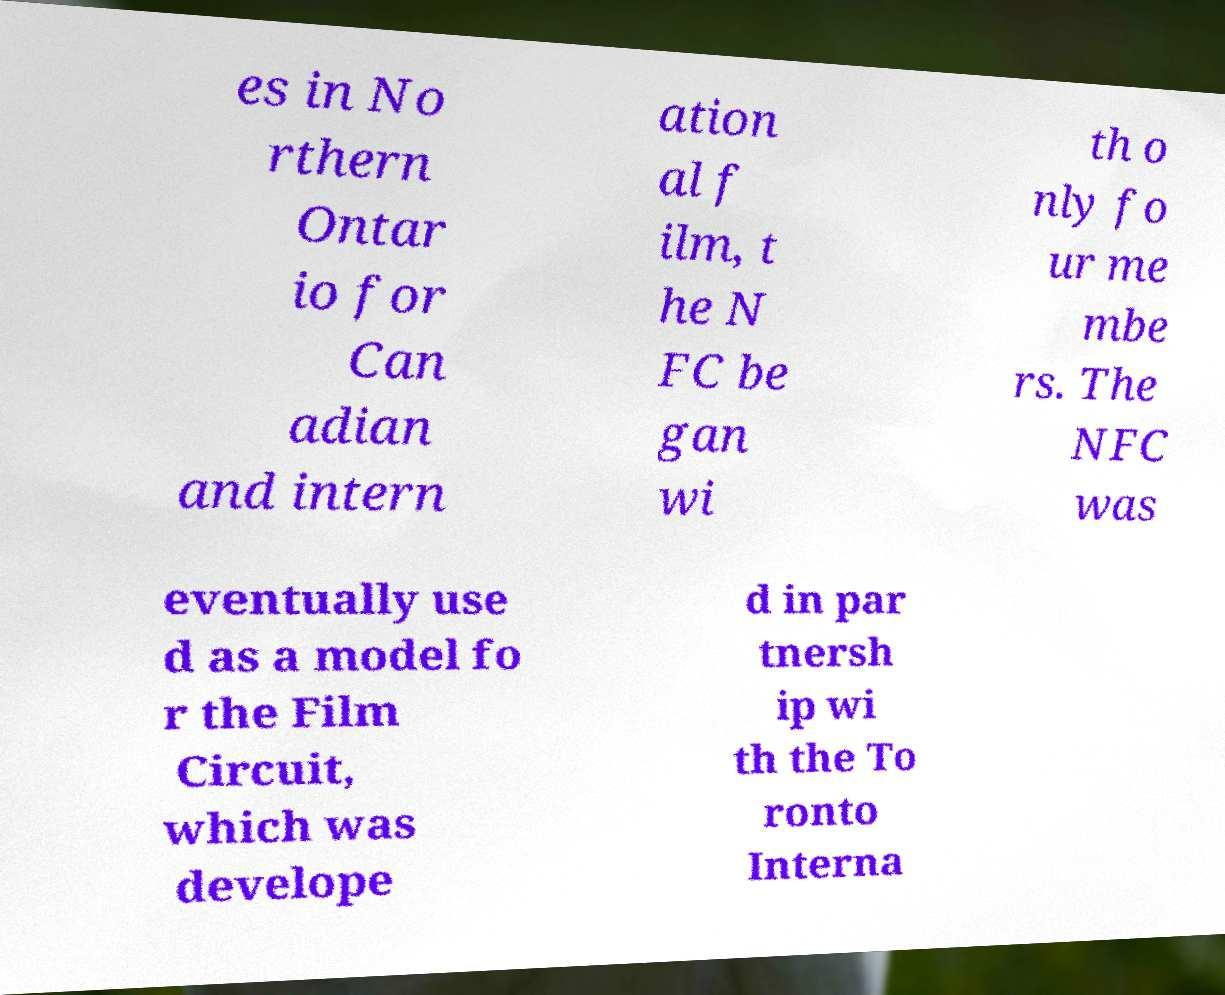For documentation purposes, I need the text within this image transcribed. Could you provide that? es in No rthern Ontar io for Can adian and intern ation al f ilm, t he N FC be gan wi th o nly fo ur me mbe rs. The NFC was eventually use d as a model fo r the Film Circuit, which was develope d in par tnersh ip wi th the To ronto Interna 